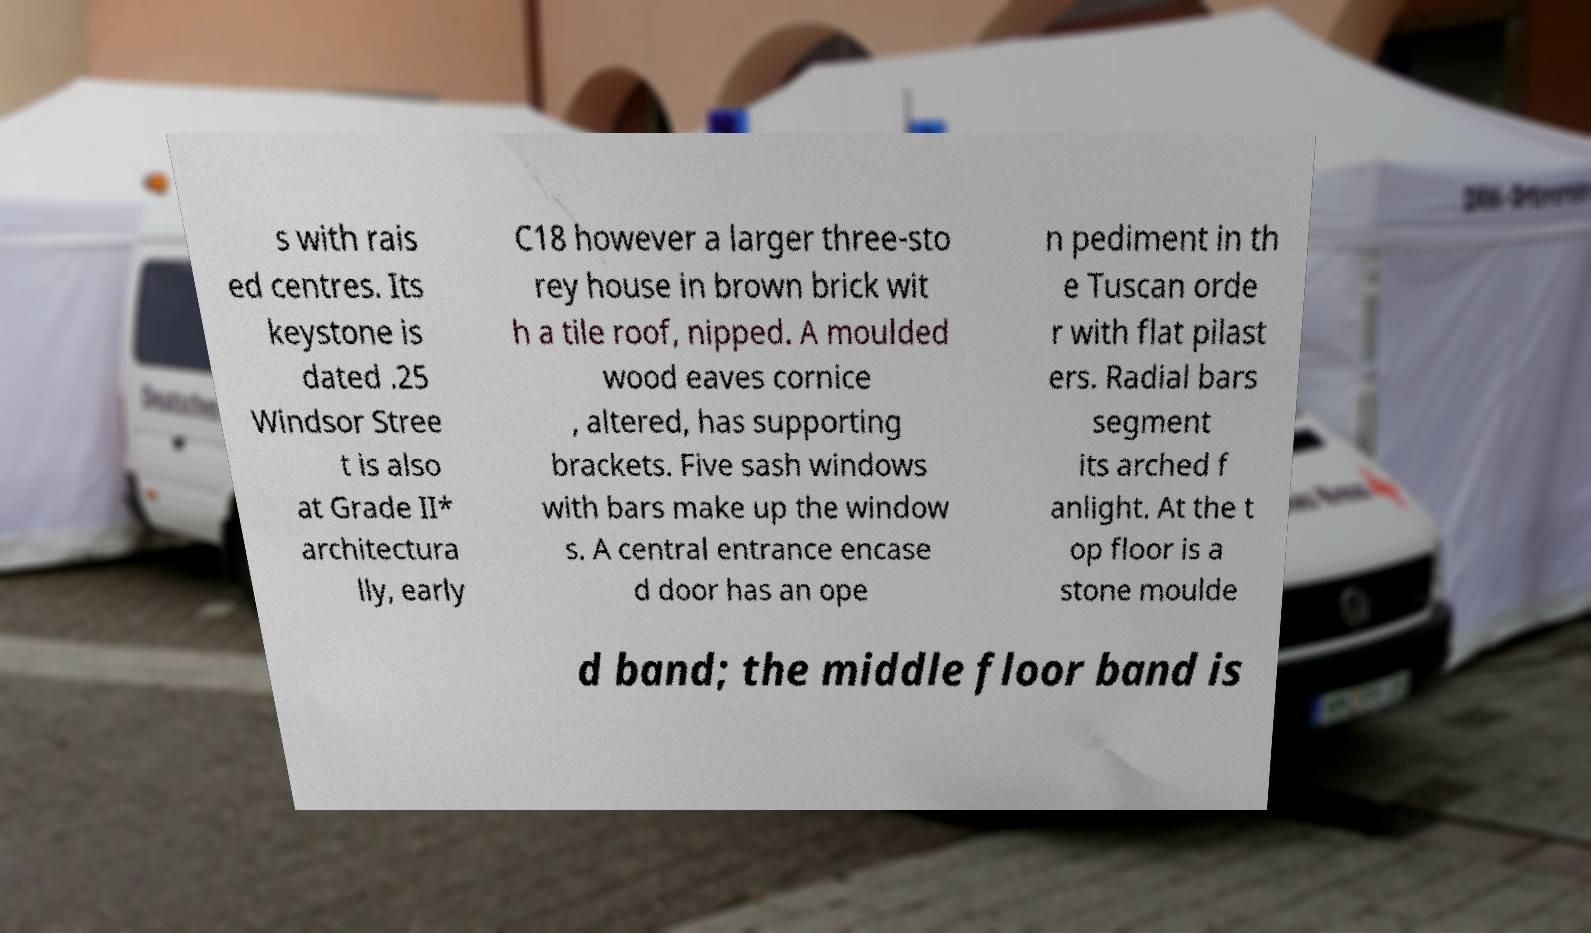Can you read and provide the text displayed in the image?This photo seems to have some interesting text. Can you extract and type it out for me? s with rais ed centres. Its keystone is dated .25 Windsor Stree t is also at Grade II* architectura lly, early C18 however a larger three-sto rey house in brown brick wit h a tile roof, nipped. A moulded wood eaves cornice , altered, has supporting brackets. Five sash windows with bars make up the window s. A central entrance encase d door has an ope n pediment in th e Tuscan orde r with flat pilast ers. Radial bars segment its arched f anlight. At the t op floor is a stone moulde d band; the middle floor band is 